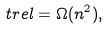<formula> <loc_0><loc_0><loc_500><loc_500>\ t r e l = \Omega ( n ^ { 2 } ) ,</formula> 